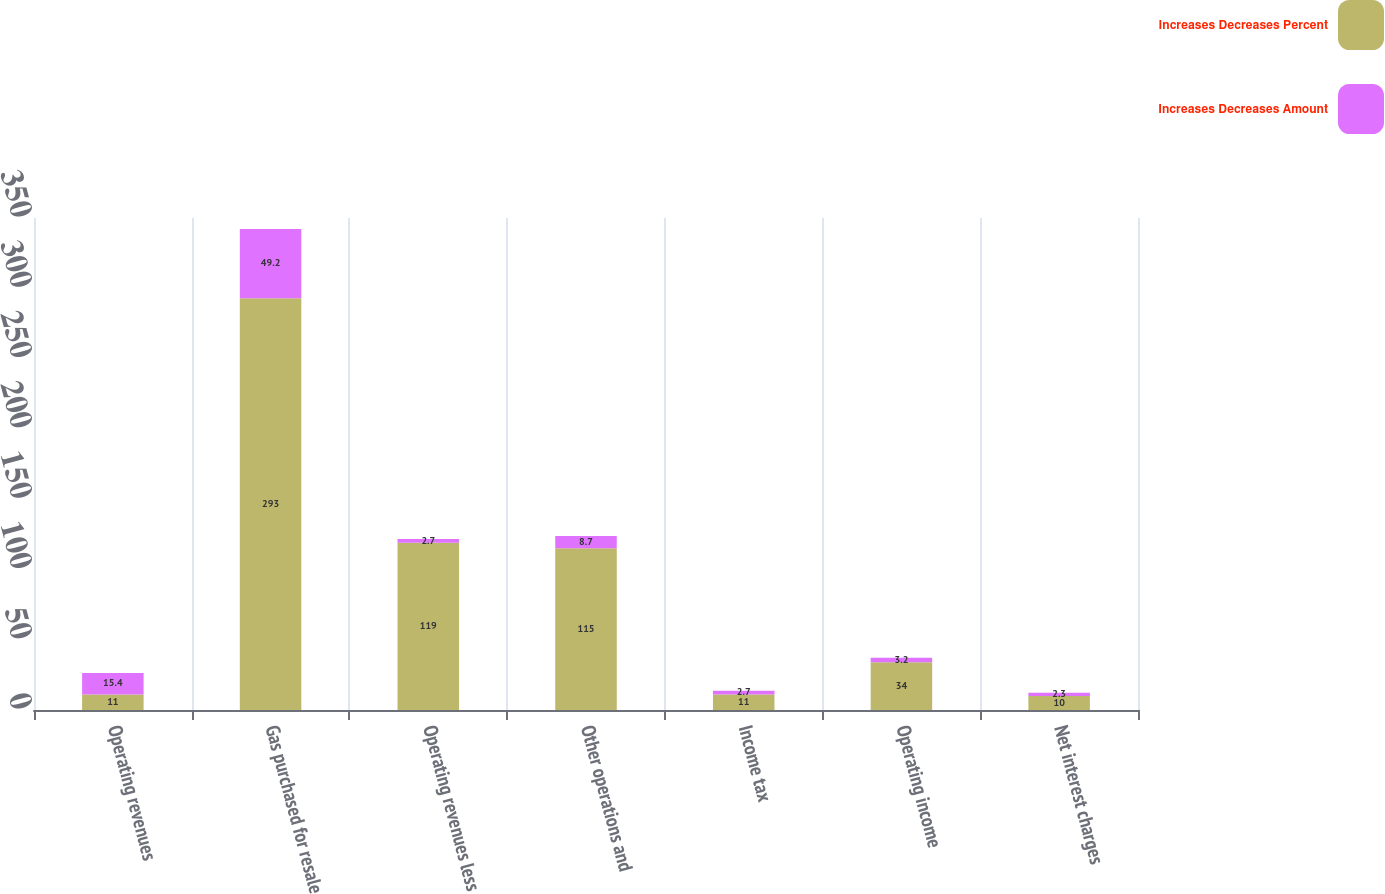<chart> <loc_0><loc_0><loc_500><loc_500><stacked_bar_chart><ecel><fcel>Operating revenues<fcel>Gas purchased for resale<fcel>Operating revenues less<fcel>Other operations and<fcel>Income tax<fcel>Operating income<fcel>Net interest charges<nl><fcel>Increases Decreases Percent<fcel>11<fcel>293<fcel>119<fcel>115<fcel>11<fcel>34<fcel>10<nl><fcel>Increases Decreases Amount<fcel>15.4<fcel>49.2<fcel>2.7<fcel>8.7<fcel>2.7<fcel>3.2<fcel>2.3<nl></chart> 